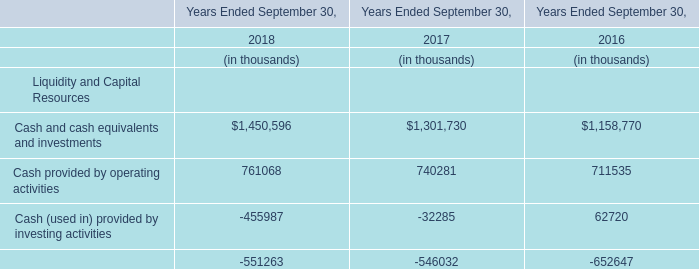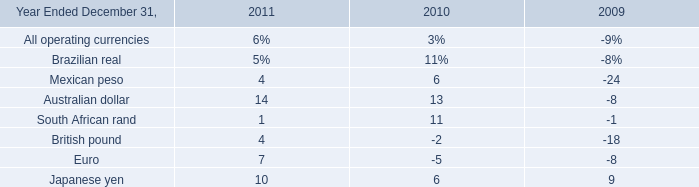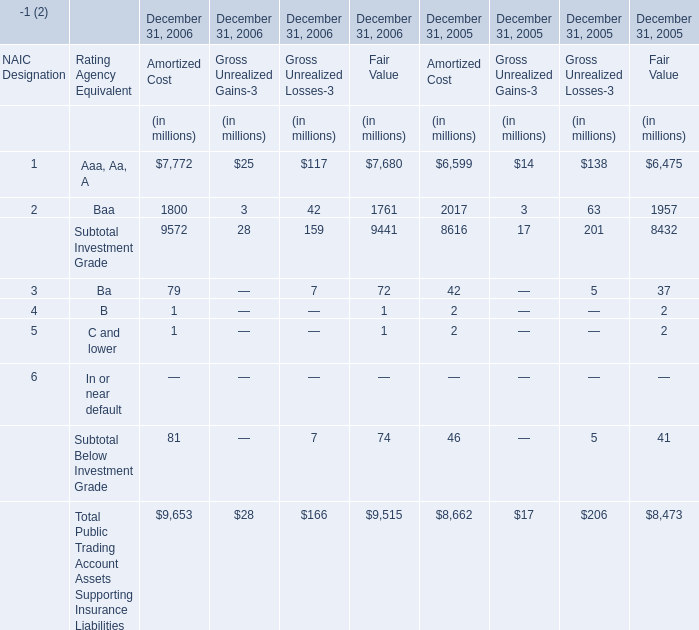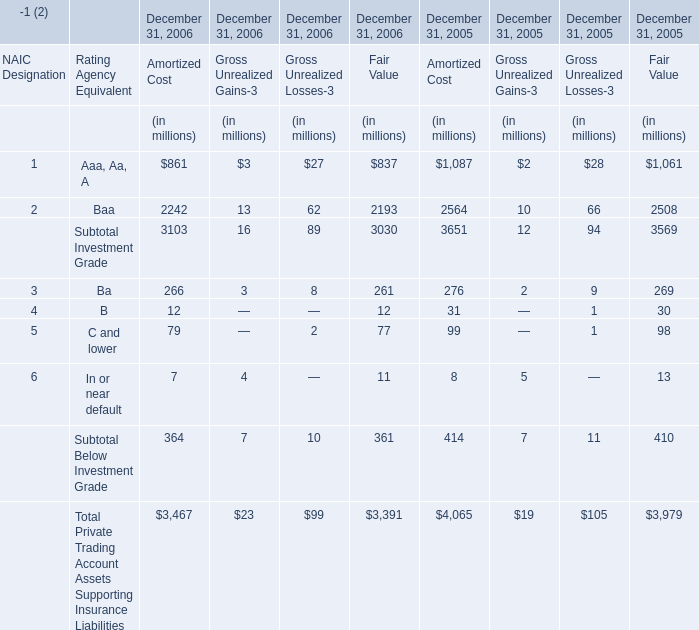What's the sum of all Gross Unrealized Gains-3 that are positive in 2005? (in million) 
Computations: (((2 + 10) + 2) + 5)
Answer: 19.0. 